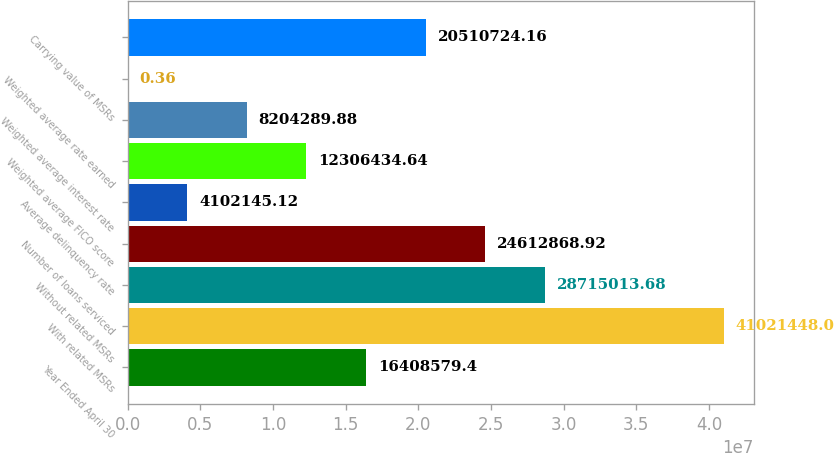Convert chart. <chart><loc_0><loc_0><loc_500><loc_500><bar_chart><fcel>Year Ended April 30<fcel>With related MSRs<fcel>Without related MSRs<fcel>Number of loans serviced<fcel>Average delinquency rate<fcel>Weighted average FICO score<fcel>Weighted average interest rate<fcel>Weighted average rate earned<fcel>Carrying value of MSRs<nl><fcel>1.64086e+07<fcel>4.10214e+07<fcel>2.8715e+07<fcel>2.46129e+07<fcel>4.10215e+06<fcel>1.23064e+07<fcel>8.20429e+06<fcel>0.36<fcel>2.05107e+07<nl></chart> 